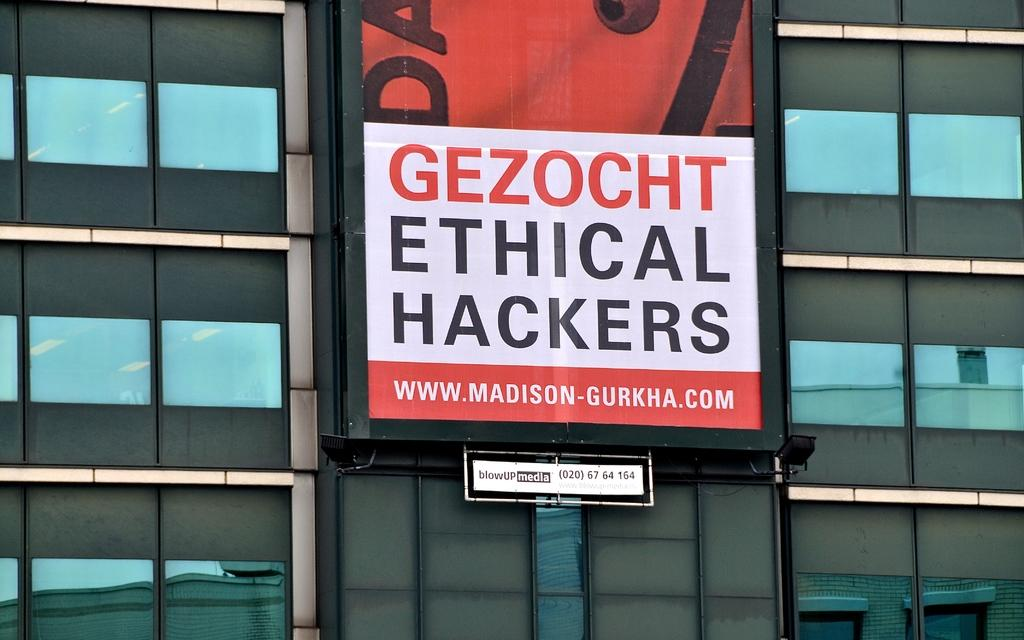What is displayed on the hoarding in the image? There is a hoarding with text in the image. What type of structure is the hoarding attached to? The hoarding is attached to a glass building. What is the other text-bearing object in the image? There is a board with text in the image. What specific information is on the board? The board has a number on it. Where is the mailbox located in the image? There is no mailbox present in the image. What type of stove is visible in the image? There is no stove present in the image. 